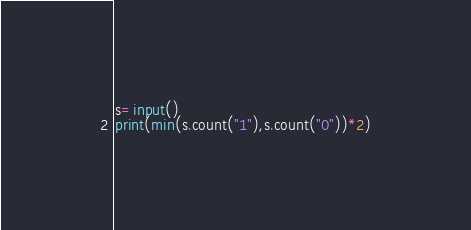Convert code to text. <code><loc_0><loc_0><loc_500><loc_500><_Python_>s=input()
print(min(s.count("1"),s.count("0"))*2)
</code> 